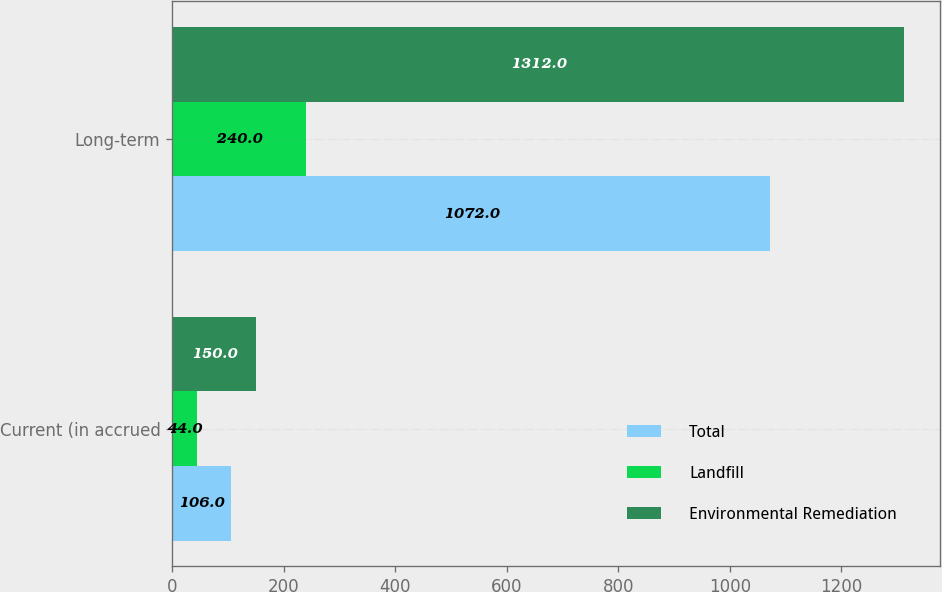Convert chart to OTSL. <chart><loc_0><loc_0><loc_500><loc_500><stacked_bar_chart><ecel><fcel>Current (in accrued<fcel>Long-term<nl><fcel>Total<fcel>106<fcel>1072<nl><fcel>Landfill<fcel>44<fcel>240<nl><fcel>Environmental Remediation<fcel>150<fcel>1312<nl></chart> 